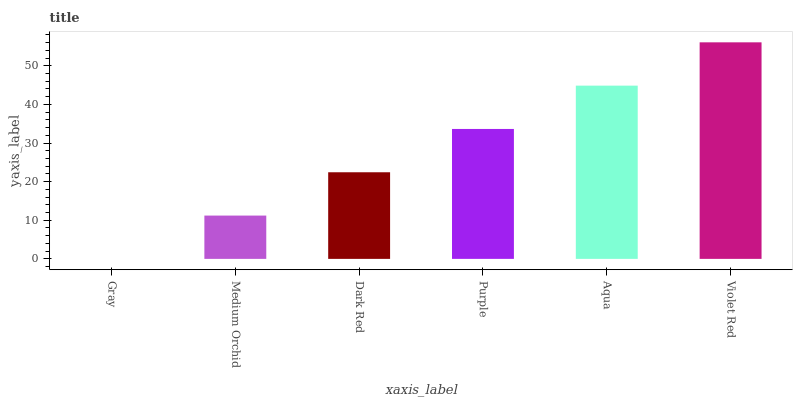Is Gray the minimum?
Answer yes or no. Yes. Is Violet Red the maximum?
Answer yes or no. Yes. Is Medium Orchid the minimum?
Answer yes or no. No. Is Medium Orchid the maximum?
Answer yes or no. No. Is Medium Orchid greater than Gray?
Answer yes or no. Yes. Is Gray less than Medium Orchid?
Answer yes or no. Yes. Is Gray greater than Medium Orchid?
Answer yes or no. No. Is Medium Orchid less than Gray?
Answer yes or no. No. Is Purple the high median?
Answer yes or no. Yes. Is Dark Red the low median?
Answer yes or no. Yes. Is Gray the high median?
Answer yes or no. No. Is Aqua the low median?
Answer yes or no. No. 